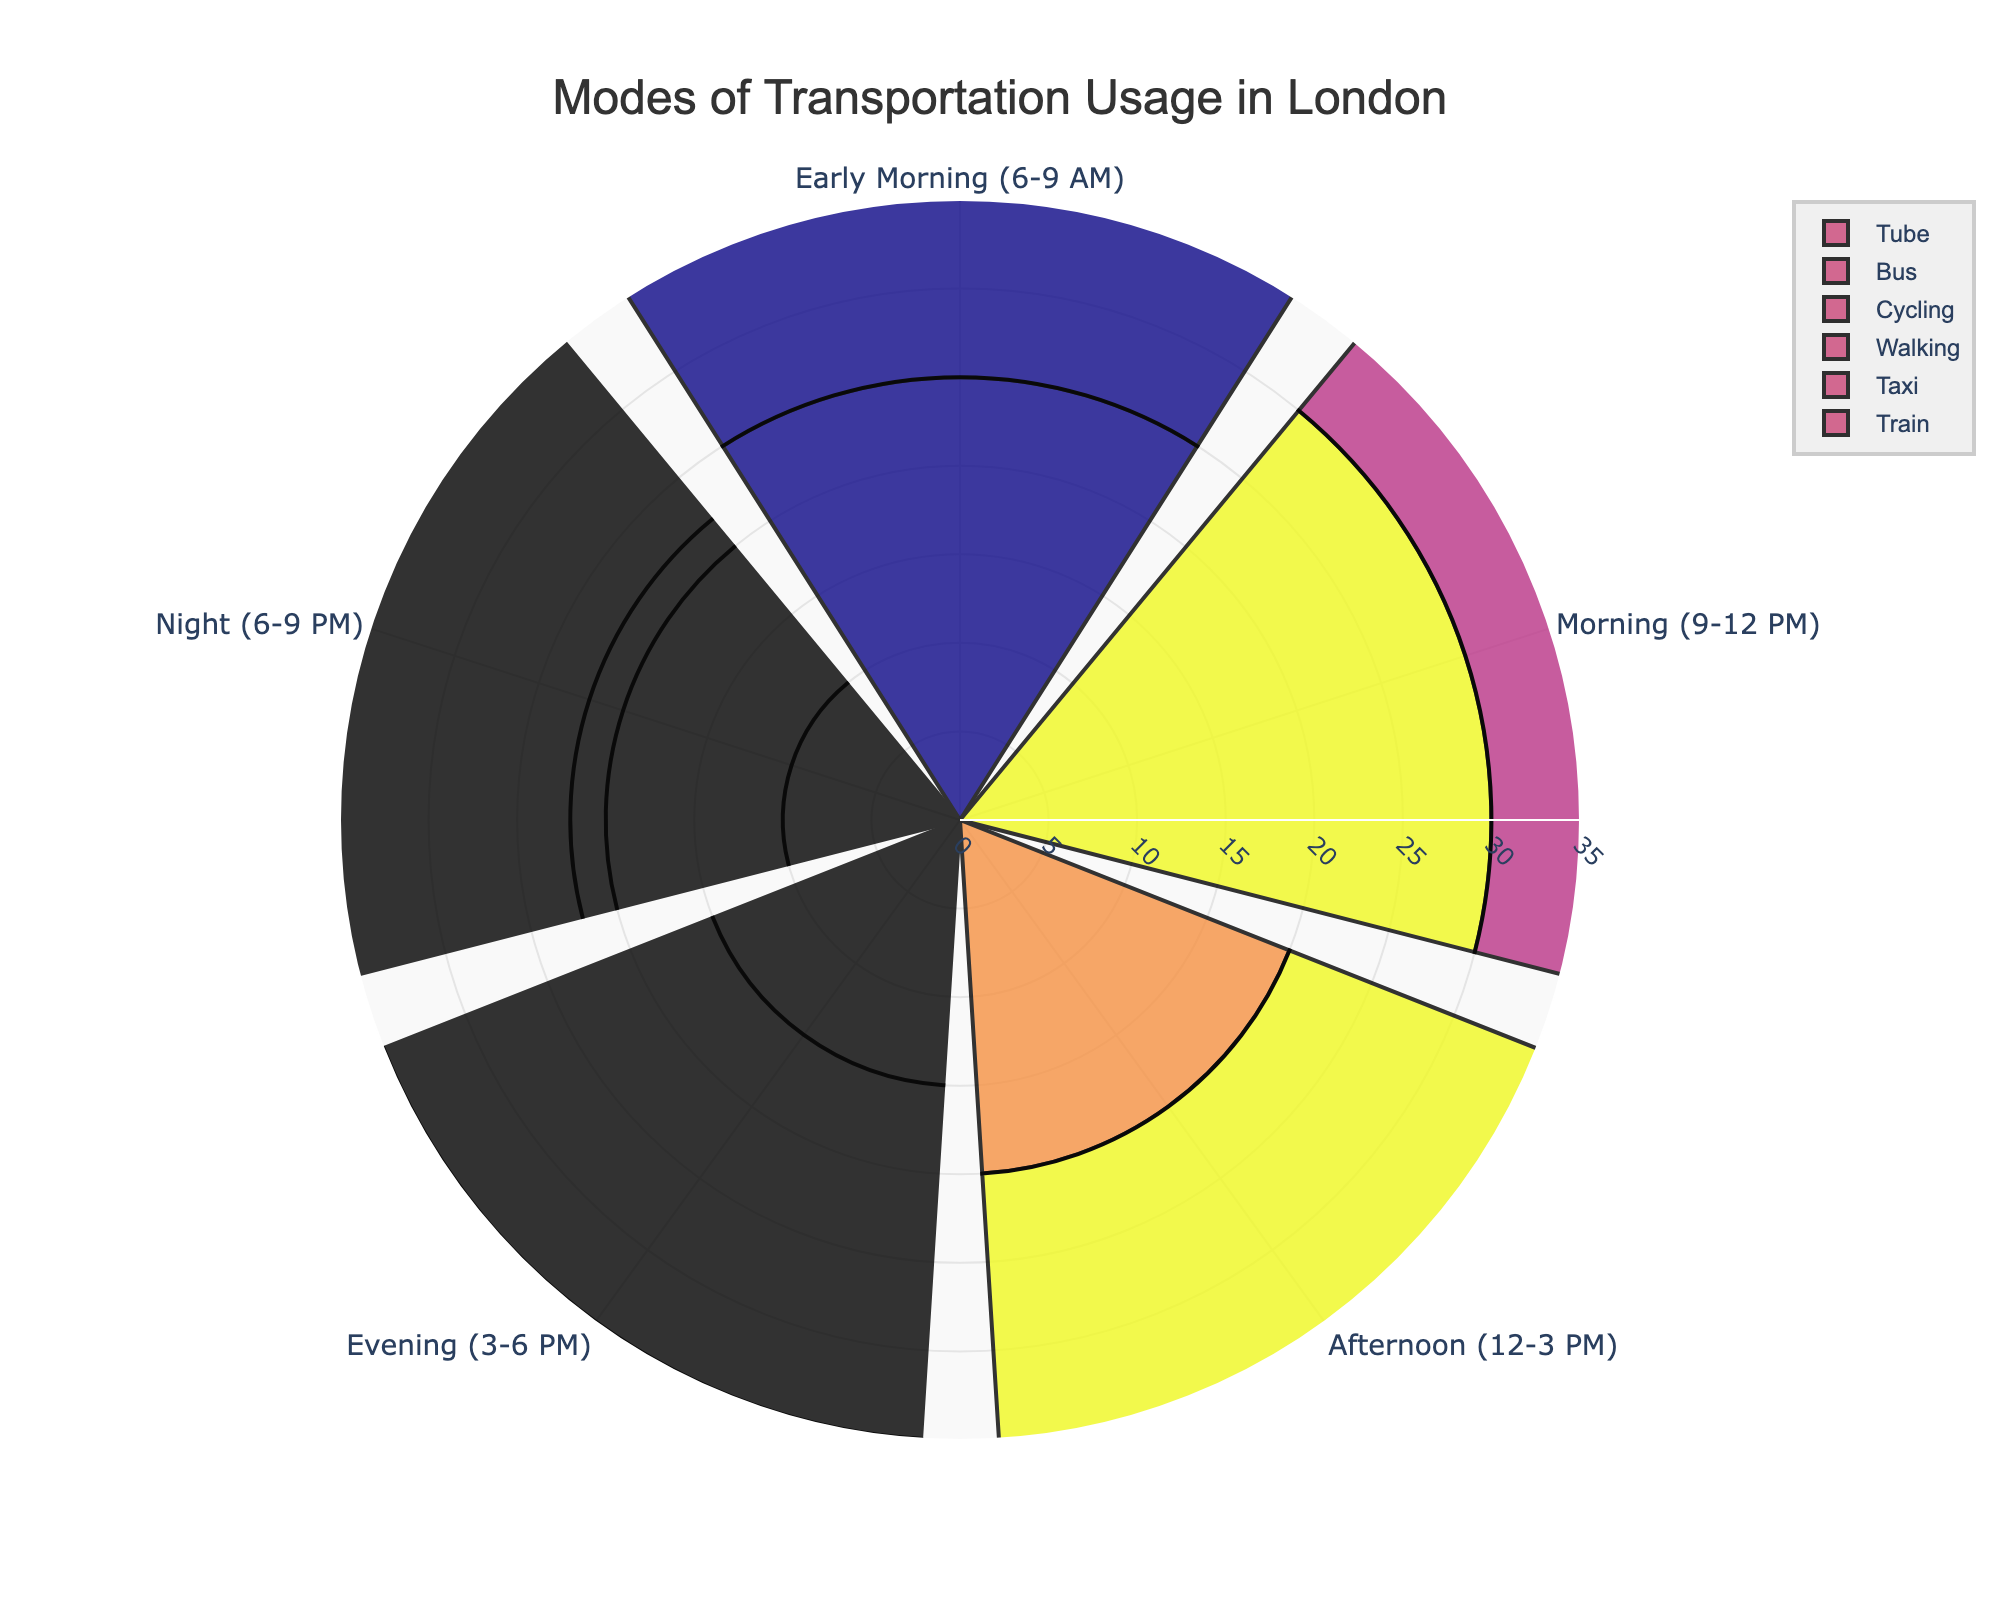What is the title of the plot? The title is usually placed at the top center part of the plot and should give an idea of what the data visualization is about. The title in this plot should be easy to locate.
Answer: Modes of Transportation Usage in London Which time of day sees the highest Tube usage? To find the highest Tube usage, look at the section with the longest radial bar for Tube. Cross-reference this with the time of day labels.
Answer: Morning (9-12 PM) What is the total percentage usage of buses throughout the day? Add up the percentage usage for buses at each time of day. The percentages are 20 + 25 + 25 + 20 + 10.
Answer: 100% During which time period is walking most popular? Identify the time period with the longest radial bar for walking. Check the corresponding time label.
Answer: Night (6-9 PM) Which mode of transportation has the smallest percentage usage during Early Morning (6-9 AM)? Compare all the radial bar lengths for each transportation mode during the Early Morning period. The shortest bar is the smallest usage.
Answer: Cycling What is the difference in percentage usage between tube and bus during the Morning (9-12 PM)? Subtract the percentage usage of the bus from the percentage usage of the tube during the morning. (Tube: 30%, Bus: 25%)
Answer: 5% Which time period has the highest combined usage of all transportation modes? Sum up the percentage usage for all transportation modes at each time period and identify the highest total.
Answer: Morning (9-12 PM) Is there any transportation mode that is used equally in two or more time periods? Look for bars of the same length within the same transportation category but in different time periods.
Answer: Bus (Afternoon (12-3 PM) and Morning (9-12 PM)) both at 25% Does the usage of cycling ever exceed that of walking? Compare the length of the radial bars for cycling and walking across all time periods.
Answer: No What is the average percentage usage of trains throughout the day? Add the percentage usages for trains at each time of day and divide by the number of periods. (30 + 15 + 15 + 10 + 5) / 5
Answer: 15% 